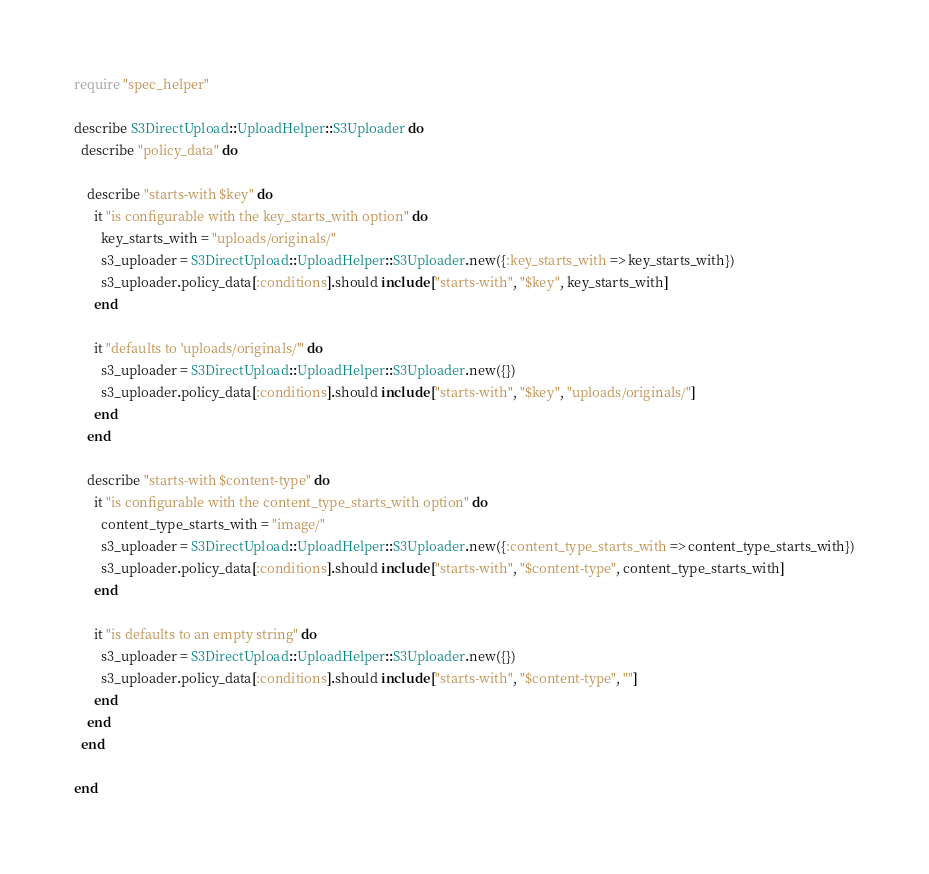<code> <loc_0><loc_0><loc_500><loc_500><_Ruby_>require "spec_helper"

describe S3DirectUpload::UploadHelper::S3Uploader do
  describe "policy_data" do

    describe "starts-with $key" do
      it "is configurable with the key_starts_with option" do
        key_starts_with = "uploads/originals/"
        s3_uploader = S3DirectUpload::UploadHelper::S3Uploader.new({:key_starts_with => key_starts_with})
        s3_uploader.policy_data[:conditions].should include ["starts-with", "$key", key_starts_with]
      end

      it "defaults to 'uploads/originals/'" do
        s3_uploader = S3DirectUpload::UploadHelper::S3Uploader.new({})
        s3_uploader.policy_data[:conditions].should include ["starts-with", "$key", "uploads/originals/"]
      end
    end

    describe "starts-with $content-type" do
      it "is configurable with the content_type_starts_with option" do
        content_type_starts_with = "image/"
        s3_uploader = S3DirectUpload::UploadHelper::S3Uploader.new({:content_type_starts_with => content_type_starts_with})
        s3_uploader.policy_data[:conditions].should include ["starts-with", "$content-type", content_type_starts_with]
      end

      it "is defaults to an empty string" do
        s3_uploader = S3DirectUpload::UploadHelper::S3Uploader.new({})
        s3_uploader.policy_data[:conditions].should include ["starts-with", "$content-type", ""]
      end
    end
  end

end
</code> 